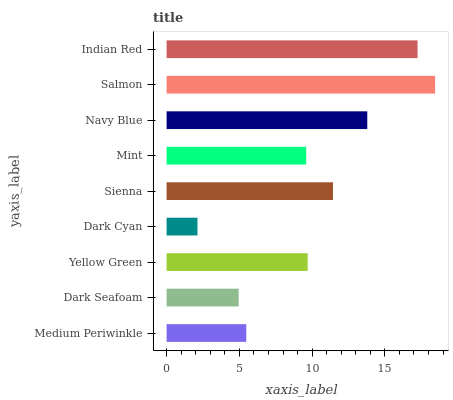Is Dark Cyan the minimum?
Answer yes or no. Yes. Is Salmon the maximum?
Answer yes or no. Yes. Is Dark Seafoam the minimum?
Answer yes or no. No. Is Dark Seafoam the maximum?
Answer yes or no. No. Is Medium Periwinkle greater than Dark Seafoam?
Answer yes or no. Yes. Is Dark Seafoam less than Medium Periwinkle?
Answer yes or no. Yes. Is Dark Seafoam greater than Medium Periwinkle?
Answer yes or no. No. Is Medium Periwinkle less than Dark Seafoam?
Answer yes or no. No. Is Yellow Green the high median?
Answer yes or no. Yes. Is Yellow Green the low median?
Answer yes or no. Yes. Is Navy Blue the high median?
Answer yes or no. No. Is Salmon the low median?
Answer yes or no. No. 